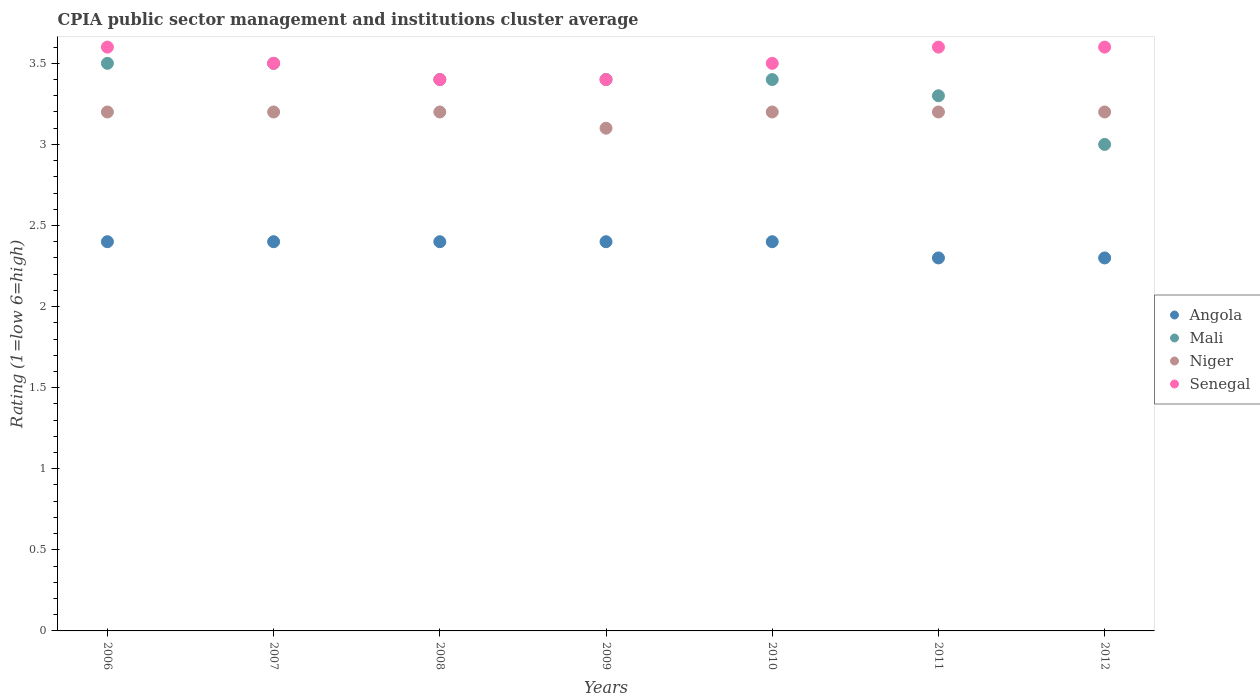How many different coloured dotlines are there?
Your answer should be compact. 4. In which year was the CPIA rating in Senegal minimum?
Your answer should be very brief. 2008. What is the total CPIA rating in Mali in the graph?
Your response must be concise. 23.5. What is the difference between the CPIA rating in Senegal in 2010 and that in 2011?
Make the answer very short. -0.1. What is the difference between the CPIA rating in Senegal in 2010 and the CPIA rating in Niger in 2008?
Make the answer very short. 0.3. What is the average CPIA rating in Mali per year?
Your response must be concise. 3.36. In how many years, is the CPIA rating in Senegal greater than 1.2?
Provide a short and direct response. 7. What is the ratio of the CPIA rating in Niger in 2006 to that in 2010?
Your answer should be compact. 1. Is the difference between the CPIA rating in Angola in 2009 and 2011 greater than the difference between the CPIA rating in Senegal in 2009 and 2011?
Your response must be concise. Yes. What is the difference between the highest and the lowest CPIA rating in Niger?
Give a very brief answer. 0.1. Does the CPIA rating in Mali monotonically increase over the years?
Make the answer very short. No. Is the CPIA rating in Angola strictly less than the CPIA rating in Mali over the years?
Keep it short and to the point. Yes. How many dotlines are there?
Provide a short and direct response. 4. What is the difference between two consecutive major ticks on the Y-axis?
Your answer should be compact. 0.5. Are the values on the major ticks of Y-axis written in scientific E-notation?
Make the answer very short. No. How are the legend labels stacked?
Make the answer very short. Vertical. What is the title of the graph?
Your answer should be very brief. CPIA public sector management and institutions cluster average. Does "Afghanistan" appear as one of the legend labels in the graph?
Provide a succinct answer. No. What is the label or title of the Y-axis?
Ensure brevity in your answer.  Rating (1=low 6=high). What is the Rating (1=low 6=high) in Angola in 2006?
Provide a succinct answer. 2.4. What is the Rating (1=low 6=high) in Mali in 2006?
Provide a short and direct response. 3.5. What is the Rating (1=low 6=high) in Niger in 2006?
Provide a succinct answer. 3.2. What is the Rating (1=low 6=high) of Senegal in 2006?
Keep it short and to the point. 3.6. What is the Rating (1=low 6=high) of Angola in 2007?
Offer a terse response. 2.4. What is the Rating (1=low 6=high) of Niger in 2007?
Make the answer very short. 3.2. What is the Rating (1=low 6=high) in Senegal in 2007?
Provide a succinct answer. 3.5. What is the Rating (1=low 6=high) of Niger in 2008?
Provide a succinct answer. 3.2. What is the Rating (1=low 6=high) of Senegal in 2008?
Offer a very short reply. 3.4. What is the Rating (1=low 6=high) of Mali in 2011?
Offer a very short reply. 3.3. What is the Rating (1=low 6=high) of Senegal in 2011?
Offer a very short reply. 3.6. Across all years, what is the maximum Rating (1=low 6=high) of Mali?
Provide a succinct answer. 3.5. Across all years, what is the minimum Rating (1=low 6=high) in Angola?
Ensure brevity in your answer.  2.3. Across all years, what is the minimum Rating (1=low 6=high) of Mali?
Make the answer very short. 3. Across all years, what is the minimum Rating (1=low 6=high) of Senegal?
Your response must be concise. 3.4. What is the total Rating (1=low 6=high) of Niger in the graph?
Offer a terse response. 22.3. What is the total Rating (1=low 6=high) in Senegal in the graph?
Provide a succinct answer. 24.6. What is the difference between the Rating (1=low 6=high) of Angola in 2006 and that in 2007?
Your response must be concise. 0. What is the difference between the Rating (1=low 6=high) in Niger in 2006 and that in 2007?
Ensure brevity in your answer.  0. What is the difference between the Rating (1=low 6=high) of Angola in 2006 and that in 2008?
Your response must be concise. 0. What is the difference between the Rating (1=low 6=high) in Mali in 2006 and that in 2008?
Your response must be concise. 0.1. What is the difference between the Rating (1=low 6=high) in Senegal in 2006 and that in 2008?
Offer a very short reply. 0.2. What is the difference between the Rating (1=low 6=high) of Angola in 2006 and that in 2009?
Provide a short and direct response. 0. What is the difference between the Rating (1=low 6=high) of Mali in 2006 and that in 2010?
Offer a very short reply. 0.1. What is the difference between the Rating (1=low 6=high) in Niger in 2006 and that in 2010?
Your answer should be very brief. 0. What is the difference between the Rating (1=low 6=high) of Angola in 2006 and that in 2011?
Offer a terse response. 0.1. What is the difference between the Rating (1=low 6=high) of Senegal in 2006 and that in 2011?
Offer a terse response. 0. What is the difference between the Rating (1=low 6=high) of Mali in 2006 and that in 2012?
Ensure brevity in your answer.  0.5. What is the difference between the Rating (1=low 6=high) in Niger in 2006 and that in 2012?
Ensure brevity in your answer.  0. What is the difference between the Rating (1=low 6=high) of Mali in 2007 and that in 2008?
Keep it short and to the point. 0.1. What is the difference between the Rating (1=low 6=high) of Niger in 2007 and that in 2008?
Keep it short and to the point. 0. What is the difference between the Rating (1=low 6=high) in Senegal in 2007 and that in 2008?
Offer a terse response. 0.1. What is the difference between the Rating (1=low 6=high) of Niger in 2007 and that in 2009?
Ensure brevity in your answer.  0.1. What is the difference between the Rating (1=low 6=high) in Senegal in 2007 and that in 2009?
Your answer should be very brief. 0.1. What is the difference between the Rating (1=low 6=high) of Mali in 2007 and that in 2010?
Provide a short and direct response. 0.1. What is the difference between the Rating (1=low 6=high) in Senegal in 2007 and that in 2010?
Provide a short and direct response. 0. What is the difference between the Rating (1=low 6=high) of Angola in 2007 and that in 2011?
Provide a succinct answer. 0.1. What is the difference between the Rating (1=low 6=high) in Mali in 2007 and that in 2011?
Provide a succinct answer. 0.2. What is the difference between the Rating (1=low 6=high) in Niger in 2007 and that in 2011?
Your response must be concise. 0. What is the difference between the Rating (1=low 6=high) of Senegal in 2007 and that in 2011?
Keep it short and to the point. -0.1. What is the difference between the Rating (1=low 6=high) in Senegal in 2007 and that in 2012?
Keep it short and to the point. -0.1. What is the difference between the Rating (1=low 6=high) in Senegal in 2008 and that in 2009?
Offer a very short reply. 0. What is the difference between the Rating (1=low 6=high) of Mali in 2008 and that in 2011?
Give a very brief answer. 0.1. What is the difference between the Rating (1=low 6=high) in Niger in 2008 and that in 2012?
Ensure brevity in your answer.  0. What is the difference between the Rating (1=low 6=high) of Mali in 2009 and that in 2010?
Ensure brevity in your answer.  0. What is the difference between the Rating (1=low 6=high) of Senegal in 2009 and that in 2010?
Your answer should be compact. -0.1. What is the difference between the Rating (1=low 6=high) of Senegal in 2009 and that in 2011?
Offer a terse response. -0.2. What is the difference between the Rating (1=low 6=high) in Angola in 2009 and that in 2012?
Provide a short and direct response. 0.1. What is the difference between the Rating (1=low 6=high) of Senegal in 2009 and that in 2012?
Offer a very short reply. -0.2. What is the difference between the Rating (1=low 6=high) in Angola in 2010 and that in 2011?
Your answer should be compact. 0.1. What is the difference between the Rating (1=low 6=high) in Mali in 2010 and that in 2011?
Provide a short and direct response. 0.1. What is the difference between the Rating (1=low 6=high) of Niger in 2010 and that in 2011?
Keep it short and to the point. 0. What is the difference between the Rating (1=low 6=high) of Senegal in 2010 and that in 2012?
Provide a short and direct response. -0.1. What is the difference between the Rating (1=low 6=high) in Angola in 2011 and that in 2012?
Ensure brevity in your answer.  0. What is the difference between the Rating (1=low 6=high) of Mali in 2011 and that in 2012?
Ensure brevity in your answer.  0.3. What is the difference between the Rating (1=low 6=high) in Niger in 2011 and that in 2012?
Keep it short and to the point. 0. What is the difference between the Rating (1=low 6=high) in Senegal in 2011 and that in 2012?
Offer a terse response. 0. What is the difference between the Rating (1=low 6=high) of Angola in 2006 and the Rating (1=low 6=high) of Mali in 2007?
Give a very brief answer. -1.1. What is the difference between the Rating (1=low 6=high) of Angola in 2006 and the Rating (1=low 6=high) of Senegal in 2007?
Provide a succinct answer. -1.1. What is the difference between the Rating (1=low 6=high) in Mali in 2006 and the Rating (1=low 6=high) in Niger in 2007?
Offer a terse response. 0.3. What is the difference between the Rating (1=low 6=high) in Mali in 2006 and the Rating (1=low 6=high) in Senegal in 2007?
Your answer should be compact. 0. What is the difference between the Rating (1=low 6=high) of Niger in 2006 and the Rating (1=low 6=high) of Senegal in 2007?
Provide a short and direct response. -0.3. What is the difference between the Rating (1=low 6=high) in Angola in 2006 and the Rating (1=low 6=high) in Mali in 2008?
Your answer should be compact. -1. What is the difference between the Rating (1=low 6=high) in Angola in 2006 and the Rating (1=low 6=high) in Niger in 2008?
Keep it short and to the point. -0.8. What is the difference between the Rating (1=low 6=high) of Mali in 2006 and the Rating (1=low 6=high) of Niger in 2008?
Your response must be concise. 0.3. What is the difference between the Rating (1=low 6=high) in Mali in 2006 and the Rating (1=low 6=high) in Senegal in 2008?
Provide a succinct answer. 0.1. What is the difference between the Rating (1=low 6=high) of Mali in 2006 and the Rating (1=low 6=high) of Niger in 2009?
Offer a terse response. 0.4. What is the difference between the Rating (1=low 6=high) of Angola in 2006 and the Rating (1=low 6=high) of Mali in 2010?
Offer a terse response. -1. What is the difference between the Rating (1=low 6=high) of Mali in 2006 and the Rating (1=low 6=high) of Senegal in 2010?
Make the answer very short. 0. What is the difference between the Rating (1=low 6=high) of Niger in 2006 and the Rating (1=low 6=high) of Senegal in 2010?
Offer a very short reply. -0.3. What is the difference between the Rating (1=low 6=high) of Angola in 2006 and the Rating (1=low 6=high) of Mali in 2011?
Offer a terse response. -0.9. What is the difference between the Rating (1=low 6=high) of Angola in 2006 and the Rating (1=low 6=high) of Niger in 2011?
Ensure brevity in your answer.  -0.8. What is the difference between the Rating (1=low 6=high) of Angola in 2006 and the Rating (1=low 6=high) of Senegal in 2011?
Your answer should be very brief. -1.2. What is the difference between the Rating (1=low 6=high) of Niger in 2006 and the Rating (1=low 6=high) of Senegal in 2011?
Provide a succinct answer. -0.4. What is the difference between the Rating (1=low 6=high) of Angola in 2006 and the Rating (1=low 6=high) of Mali in 2012?
Offer a terse response. -0.6. What is the difference between the Rating (1=low 6=high) of Angola in 2006 and the Rating (1=low 6=high) of Niger in 2012?
Your response must be concise. -0.8. What is the difference between the Rating (1=low 6=high) of Angola in 2006 and the Rating (1=low 6=high) of Senegal in 2012?
Offer a very short reply. -1.2. What is the difference between the Rating (1=low 6=high) of Mali in 2006 and the Rating (1=low 6=high) of Niger in 2012?
Offer a very short reply. 0.3. What is the difference between the Rating (1=low 6=high) in Niger in 2006 and the Rating (1=low 6=high) in Senegal in 2012?
Give a very brief answer. -0.4. What is the difference between the Rating (1=low 6=high) of Angola in 2007 and the Rating (1=low 6=high) of Mali in 2008?
Give a very brief answer. -1. What is the difference between the Rating (1=low 6=high) of Angola in 2007 and the Rating (1=low 6=high) of Niger in 2008?
Keep it short and to the point. -0.8. What is the difference between the Rating (1=low 6=high) in Mali in 2007 and the Rating (1=low 6=high) in Niger in 2008?
Provide a succinct answer. 0.3. What is the difference between the Rating (1=low 6=high) in Niger in 2007 and the Rating (1=low 6=high) in Senegal in 2008?
Provide a short and direct response. -0.2. What is the difference between the Rating (1=low 6=high) in Angola in 2007 and the Rating (1=low 6=high) in Niger in 2009?
Offer a terse response. -0.7. What is the difference between the Rating (1=low 6=high) of Mali in 2007 and the Rating (1=low 6=high) of Senegal in 2009?
Give a very brief answer. 0.1. What is the difference between the Rating (1=low 6=high) of Mali in 2007 and the Rating (1=low 6=high) of Senegal in 2010?
Offer a very short reply. 0. What is the difference between the Rating (1=low 6=high) of Niger in 2007 and the Rating (1=low 6=high) of Senegal in 2010?
Ensure brevity in your answer.  -0.3. What is the difference between the Rating (1=low 6=high) in Angola in 2007 and the Rating (1=low 6=high) in Niger in 2011?
Your answer should be compact. -0.8. What is the difference between the Rating (1=low 6=high) in Mali in 2007 and the Rating (1=low 6=high) in Senegal in 2011?
Provide a short and direct response. -0.1. What is the difference between the Rating (1=low 6=high) in Niger in 2007 and the Rating (1=low 6=high) in Senegal in 2011?
Provide a succinct answer. -0.4. What is the difference between the Rating (1=low 6=high) in Angola in 2007 and the Rating (1=low 6=high) in Mali in 2012?
Ensure brevity in your answer.  -0.6. What is the difference between the Rating (1=low 6=high) in Angola in 2007 and the Rating (1=low 6=high) in Niger in 2012?
Provide a short and direct response. -0.8. What is the difference between the Rating (1=low 6=high) in Angola in 2007 and the Rating (1=low 6=high) in Senegal in 2012?
Your answer should be compact. -1.2. What is the difference between the Rating (1=low 6=high) of Mali in 2007 and the Rating (1=low 6=high) of Senegal in 2012?
Offer a terse response. -0.1. What is the difference between the Rating (1=low 6=high) of Niger in 2007 and the Rating (1=low 6=high) of Senegal in 2012?
Provide a succinct answer. -0.4. What is the difference between the Rating (1=low 6=high) of Angola in 2008 and the Rating (1=low 6=high) of Niger in 2009?
Make the answer very short. -0.7. What is the difference between the Rating (1=low 6=high) in Angola in 2008 and the Rating (1=low 6=high) in Senegal in 2009?
Provide a succinct answer. -1. What is the difference between the Rating (1=low 6=high) of Angola in 2008 and the Rating (1=low 6=high) of Mali in 2010?
Your response must be concise. -1. What is the difference between the Rating (1=low 6=high) of Angola in 2008 and the Rating (1=low 6=high) of Mali in 2011?
Make the answer very short. -0.9. What is the difference between the Rating (1=low 6=high) of Angola in 2008 and the Rating (1=low 6=high) of Niger in 2011?
Your answer should be very brief. -0.8. What is the difference between the Rating (1=low 6=high) in Mali in 2008 and the Rating (1=low 6=high) in Niger in 2011?
Your response must be concise. 0.2. What is the difference between the Rating (1=low 6=high) of Niger in 2008 and the Rating (1=low 6=high) of Senegal in 2011?
Give a very brief answer. -0.4. What is the difference between the Rating (1=low 6=high) of Angola in 2008 and the Rating (1=low 6=high) of Niger in 2012?
Give a very brief answer. -0.8. What is the difference between the Rating (1=low 6=high) in Mali in 2008 and the Rating (1=low 6=high) in Niger in 2012?
Provide a succinct answer. 0.2. What is the difference between the Rating (1=low 6=high) in Niger in 2008 and the Rating (1=low 6=high) in Senegal in 2012?
Ensure brevity in your answer.  -0.4. What is the difference between the Rating (1=low 6=high) of Angola in 2009 and the Rating (1=low 6=high) of Senegal in 2010?
Keep it short and to the point. -1.1. What is the difference between the Rating (1=low 6=high) of Mali in 2009 and the Rating (1=low 6=high) of Niger in 2010?
Make the answer very short. 0.2. What is the difference between the Rating (1=low 6=high) in Angola in 2009 and the Rating (1=low 6=high) in Mali in 2011?
Your answer should be very brief. -0.9. What is the difference between the Rating (1=low 6=high) in Mali in 2009 and the Rating (1=low 6=high) in Niger in 2011?
Offer a very short reply. 0.2. What is the difference between the Rating (1=low 6=high) in Mali in 2009 and the Rating (1=low 6=high) in Senegal in 2011?
Ensure brevity in your answer.  -0.2. What is the difference between the Rating (1=low 6=high) in Niger in 2009 and the Rating (1=low 6=high) in Senegal in 2011?
Provide a short and direct response. -0.5. What is the difference between the Rating (1=low 6=high) of Angola in 2009 and the Rating (1=low 6=high) of Mali in 2012?
Give a very brief answer. -0.6. What is the difference between the Rating (1=low 6=high) of Angola in 2009 and the Rating (1=low 6=high) of Senegal in 2012?
Make the answer very short. -1.2. What is the difference between the Rating (1=low 6=high) in Mali in 2009 and the Rating (1=low 6=high) in Niger in 2012?
Offer a very short reply. 0.2. What is the difference between the Rating (1=low 6=high) in Niger in 2009 and the Rating (1=low 6=high) in Senegal in 2012?
Provide a succinct answer. -0.5. What is the difference between the Rating (1=low 6=high) in Angola in 2010 and the Rating (1=low 6=high) in Mali in 2011?
Ensure brevity in your answer.  -0.9. What is the difference between the Rating (1=low 6=high) of Angola in 2010 and the Rating (1=low 6=high) of Senegal in 2011?
Provide a succinct answer. -1.2. What is the difference between the Rating (1=low 6=high) of Mali in 2010 and the Rating (1=low 6=high) of Senegal in 2011?
Keep it short and to the point. -0.2. What is the difference between the Rating (1=low 6=high) of Angola in 2010 and the Rating (1=low 6=high) of Mali in 2012?
Your response must be concise. -0.6. What is the difference between the Rating (1=low 6=high) of Angola in 2010 and the Rating (1=low 6=high) of Senegal in 2012?
Your answer should be compact. -1.2. What is the difference between the Rating (1=low 6=high) in Mali in 2010 and the Rating (1=low 6=high) in Niger in 2012?
Your answer should be very brief. 0.2. What is the difference between the Rating (1=low 6=high) of Niger in 2010 and the Rating (1=low 6=high) of Senegal in 2012?
Offer a terse response. -0.4. What is the difference between the Rating (1=low 6=high) of Angola in 2011 and the Rating (1=low 6=high) of Mali in 2012?
Your response must be concise. -0.7. What is the difference between the Rating (1=low 6=high) in Angola in 2011 and the Rating (1=low 6=high) in Niger in 2012?
Offer a terse response. -0.9. What is the difference between the Rating (1=low 6=high) of Angola in 2011 and the Rating (1=low 6=high) of Senegal in 2012?
Your answer should be compact. -1.3. What is the difference between the Rating (1=low 6=high) of Mali in 2011 and the Rating (1=low 6=high) of Niger in 2012?
Provide a succinct answer. 0.1. What is the difference between the Rating (1=low 6=high) in Niger in 2011 and the Rating (1=low 6=high) in Senegal in 2012?
Offer a very short reply. -0.4. What is the average Rating (1=low 6=high) in Angola per year?
Your response must be concise. 2.37. What is the average Rating (1=low 6=high) in Mali per year?
Ensure brevity in your answer.  3.36. What is the average Rating (1=low 6=high) in Niger per year?
Give a very brief answer. 3.19. What is the average Rating (1=low 6=high) in Senegal per year?
Ensure brevity in your answer.  3.51. In the year 2006, what is the difference between the Rating (1=low 6=high) of Angola and Rating (1=low 6=high) of Niger?
Ensure brevity in your answer.  -0.8. In the year 2006, what is the difference between the Rating (1=low 6=high) in Angola and Rating (1=low 6=high) in Senegal?
Give a very brief answer. -1.2. In the year 2006, what is the difference between the Rating (1=low 6=high) in Mali and Rating (1=low 6=high) in Senegal?
Ensure brevity in your answer.  -0.1. In the year 2006, what is the difference between the Rating (1=low 6=high) of Niger and Rating (1=low 6=high) of Senegal?
Your response must be concise. -0.4. In the year 2007, what is the difference between the Rating (1=low 6=high) of Angola and Rating (1=low 6=high) of Senegal?
Provide a short and direct response. -1.1. In the year 2007, what is the difference between the Rating (1=low 6=high) of Mali and Rating (1=low 6=high) of Niger?
Keep it short and to the point. 0.3. In the year 2007, what is the difference between the Rating (1=low 6=high) in Niger and Rating (1=low 6=high) in Senegal?
Your answer should be compact. -0.3. In the year 2008, what is the difference between the Rating (1=low 6=high) of Angola and Rating (1=low 6=high) of Mali?
Keep it short and to the point. -1. In the year 2008, what is the difference between the Rating (1=low 6=high) of Angola and Rating (1=low 6=high) of Niger?
Provide a short and direct response. -0.8. In the year 2008, what is the difference between the Rating (1=low 6=high) of Mali and Rating (1=low 6=high) of Niger?
Provide a succinct answer. 0.2. In the year 2008, what is the difference between the Rating (1=low 6=high) in Niger and Rating (1=low 6=high) in Senegal?
Your answer should be very brief. -0.2. In the year 2009, what is the difference between the Rating (1=low 6=high) of Angola and Rating (1=low 6=high) of Mali?
Offer a terse response. -1. In the year 2009, what is the difference between the Rating (1=low 6=high) in Angola and Rating (1=low 6=high) in Niger?
Offer a terse response. -0.7. In the year 2009, what is the difference between the Rating (1=low 6=high) in Mali and Rating (1=low 6=high) in Senegal?
Provide a succinct answer. 0. In the year 2009, what is the difference between the Rating (1=low 6=high) of Niger and Rating (1=low 6=high) of Senegal?
Your answer should be very brief. -0.3. In the year 2010, what is the difference between the Rating (1=low 6=high) in Angola and Rating (1=low 6=high) in Mali?
Offer a terse response. -1. In the year 2010, what is the difference between the Rating (1=low 6=high) of Angola and Rating (1=low 6=high) of Niger?
Your answer should be very brief. -0.8. In the year 2010, what is the difference between the Rating (1=low 6=high) in Angola and Rating (1=low 6=high) in Senegal?
Offer a very short reply. -1.1. In the year 2010, what is the difference between the Rating (1=low 6=high) of Mali and Rating (1=low 6=high) of Senegal?
Make the answer very short. -0.1. In the year 2011, what is the difference between the Rating (1=low 6=high) of Angola and Rating (1=low 6=high) of Niger?
Keep it short and to the point. -0.9. In the year 2011, what is the difference between the Rating (1=low 6=high) of Angola and Rating (1=low 6=high) of Senegal?
Offer a terse response. -1.3. In the year 2011, what is the difference between the Rating (1=low 6=high) of Mali and Rating (1=low 6=high) of Niger?
Offer a terse response. 0.1. In the year 2012, what is the difference between the Rating (1=low 6=high) of Mali and Rating (1=low 6=high) of Senegal?
Your answer should be very brief. -0.6. In the year 2012, what is the difference between the Rating (1=low 6=high) in Niger and Rating (1=low 6=high) in Senegal?
Your answer should be very brief. -0.4. What is the ratio of the Rating (1=low 6=high) of Angola in 2006 to that in 2007?
Your response must be concise. 1. What is the ratio of the Rating (1=low 6=high) of Niger in 2006 to that in 2007?
Ensure brevity in your answer.  1. What is the ratio of the Rating (1=low 6=high) in Senegal in 2006 to that in 2007?
Ensure brevity in your answer.  1.03. What is the ratio of the Rating (1=low 6=high) in Mali in 2006 to that in 2008?
Provide a short and direct response. 1.03. What is the ratio of the Rating (1=low 6=high) of Senegal in 2006 to that in 2008?
Offer a terse response. 1.06. What is the ratio of the Rating (1=low 6=high) in Angola in 2006 to that in 2009?
Provide a short and direct response. 1. What is the ratio of the Rating (1=low 6=high) in Mali in 2006 to that in 2009?
Offer a very short reply. 1.03. What is the ratio of the Rating (1=low 6=high) of Niger in 2006 to that in 2009?
Your answer should be compact. 1.03. What is the ratio of the Rating (1=low 6=high) of Senegal in 2006 to that in 2009?
Offer a terse response. 1.06. What is the ratio of the Rating (1=low 6=high) of Angola in 2006 to that in 2010?
Ensure brevity in your answer.  1. What is the ratio of the Rating (1=low 6=high) of Mali in 2006 to that in 2010?
Your answer should be very brief. 1.03. What is the ratio of the Rating (1=low 6=high) of Niger in 2006 to that in 2010?
Provide a short and direct response. 1. What is the ratio of the Rating (1=low 6=high) of Senegal in 2006 to that in 2010?
Your answer should be compact. 1.03. What is the ratio of the Rating (1=low 6=high) in Angola in 2006 to that in 2011?
Offer a very short reply. 1.04. What is the ratio of the Rating (1=low 6=high) in Mali in 2006 to that in 2011?
Offer a very short reply. 1.06. What is the ratio of the Rating (1=low 6=high) in Niger in 2006 to that in 2011?
Ensure brevity in your answer.  1. What is the ratio of the Rating (1=low 6=high) in Angola in 2006 to that in 2012?
Provide a short and direct response. 1.04. What is the ratio of the Rating (1=low 6=high) in Senegal in 2006 to that in 2012?
Your answer should be very brief. 1. What is the ratio of the Rating (1=low 6=high) of Angola in 2007 to that in 2008?
Your answer should be very brief. 1. What is the ratio of the Rating (1=low 6=high) in Mali in 2007 to that in 2008?
Give a very brief answer. 1.03. What is the ratio of the Rating (1=low 6=high) in Niger in 2007 to that in 2008?
Provide a succinct answer. 1. What is the ratio of the Rating (1=low 6=high) in Senegal in 2007 to that in 2008?
Offer a terse response. 1.03. What is the ratio of the Rating (1=low 6=high) in Angola in 2007 to that in 2009?
Provide a succinct answer. 1. What is the ratio of the Rating (1=low 6=high) in Mali in 2007 to that in 2009?
Your response must be concise. 1.03. What is the ratio of the Rating (1=low 6=high) of Niger in 2007 to that in 2009?
Provide a short and direct response. 1.03. What is the ratio of the Rating (1=low 6=high) of Senegal in 2007 to that in 2009?
Ensure brevity in your answer.  1.03. What is the ratio of the Rating (1=low 6=high) of Mali in 2007 to that in 2010?
Ensure brevity in your answer.  1.03. What is the ratio of the Rating (1=low 6=high) in Angola in 2007 to that in 2011?
Keep it short and to the point. 1.04. What is the ratio of the Rating (1=low 6=high) in Mali in 2007 to that in 2011?
Offer a terse response. 1.06. What is the ratio of the Rating (1=low 6=high) of Niger in 2007 to that in 2011?
Your answer should be compact. 1. What is the ratio of the Rating (1=low 6=high) in Senegal in 2007 to that in 2011?
Your response must be concise. 0.97. What is the ratio of the Rating (1=low 6=high) in Angola in 2007 to that in 2012?
Your answer should be very brief. 1.04. What is the ratio of the Rating (1=low 6=high) in Mali in 2007 to that in 2012?
Your answer should be very brief. 1.17. What is the ratio of the Rating (1=low 6=high) in Senegal in 2007 to that in 2012?
Your answer should be very brief. 0.97. What is the ratio of the Rating (1=low 6=high) in Mali in 2008 to that in 2009?
Provide a short and direct response. 1. What is the ratio of the Rating (1=low 6=high) in Niger in 2008 to that in 2009?
Provide a short and direct response. 1.03. What is the ratio of the Rating (1=low 6=high) of Senegal in 2008 to that in 2009?
Give a very brief answer. 1. What is the ratio of the Rating (1=low 6=high) of Angola in 2008 to that in 2010?
Offer a terse response. 1. What is the ratio of the Rating (1=low 6=high) in Mali in 2008 to that in 2010?
Your response must be concise. 1. What is the ratio of the Rating (1=low 6=high) of Senegal in 2008 to that in 2010?
Keep it short and to the point. 0.97. What is the ratio of the Rating (1=low 6=high) in Angola in 2008 to that in 2011?
Offer a terse response. 1.04. What is the ratio of the Rating (1=low 6=high) in Mali in 2008 to that in 2011?
Offer a very short reply. 1.03. What is the ratio of the Rating (1=low 6=high) of Senegal in 2008 to that in 2011?
Make the answer very short. 0.94. What is the ratio of the Rating (1=low 6=high) of Angola in 2008 to that in 2012?
Your answer should be very brief. 1.04. What is the ratio of the Rating (1=low 6=high) of Mali in 2008 to that in 2012?
Your answer should be very brief. 1.13. What is the ratio of the Rating (1=low 6=high) of Niger in 2008 to that in 2012?
Provide a succinct answer. 1. What is the ratio of the Rating (1=low 6=high) of Senegal in 2008 to that in 2012?
Your response must be concise. 0.94. What is the ratio of the Rating (1=low 6=high) of Angola in 2009 to that in 2010?
Your response must be concise. 1. What is the ratio of the Rating (1=low 6=high) in Mali in 2009 to that in 2010?
Provide a short and direct response. 1. What is the ratio of the Rating (1=low 6=high) of Niger in 2009 to that in 2010?
Your answer should be compact. 0.97. What is the ratio of the Rating (1=low 6=high) in Senegal in 2009 to that in 2010?
Ensure brevity in your answer.  0.97. What is the ratio of the Rating (1=low 6=high) of Angola in 2009 to that in 2011?
Provide a succinct answer. 1.04. What is the ratio of the Rating (1=low 6=high) of Mali in 2009 to that in 2011?
Make the answer very short. 1.03. What is the ratio of the Rating (1=low 6=high) in Niger in 2009 to that in 2011?
Keep it short and to the point. 0.97. What is the ratio of the Rating (1=low 6=high) of Angola in 2009 to that in 2012?
Offer a terse response. 1.04. What is the ratio of the Rating (1=low 6=high) in Mali in 2009 to that in 2012?
Give a very brief answer. 1.13. What is the ratio of the Rating (1=low 6=high) in Niger in 2009 to that in 2012?
Provide a short and direct response. 0.97. What is the ratio of the Rating (1=low 6=high) in Senegal in 2009 to that in 2012?
Your answer should be very brief. 0.94. What is the ratio of the Rating (1=low 6=high) in Angola in 2010 to that in 2011?
Provide a short and direct response. 1.04. What is the ratio of the Rating (1=low 6=high) in Mali in 2010 to that in 2011?
Offer a terse response. 1.03. What is the ratio of the Rating (1=low 6=high) of Senegal in 2010 to that in 2011?
Ensure brevity in your answer.  0.97. What is the ratio of the Rating (1=low 6=high) in Angola in 2010 to that in 2012?
Give a very brief answer. 1.04. What is the ratio of the Rating (1=low 6=high) in Mali in 2010 to that in 2012?
Ensure brevity in your answer.  1.13. What is the ratio of the Rating (1=low 6=high) in Niger in 2010 to that in 2012?
Your response must be concise. 1. What is the ratio of the Rating (1=low 6=high) of Senegal in 2010 to that in 2012?
Make the answer very short. 0.97. What is the ratio of the Rating (1=low 6=high) in Angola in 2011 to that in 2012?
Provide a succinct answer. 1. What is the difference between the highest and the second highest Rating (1=low 6=high) of Angola?
Keep it short and to the point. 0. What is the difference between the highest and the second highest Rating (1=low 6=high) of Mali?
Your answer should be compact. 0. What is the difference between the highest and the second highest Rating (1=low 6=high) of Niger?
Provide a succinct answer. 0. What is the difference between the highest and the second highest Rating (1=low 6=high) in Senegal?
Your answer should be very brief. 0. What is the difference between the highest and the lowest Rating (1=low 6=high) in Angola?
Make the answer very short. 0.1. What is the difference between the highest and the lowest Rating (1=low 6=high) of Senegal?
Your answer should be very brief. 0.2. 